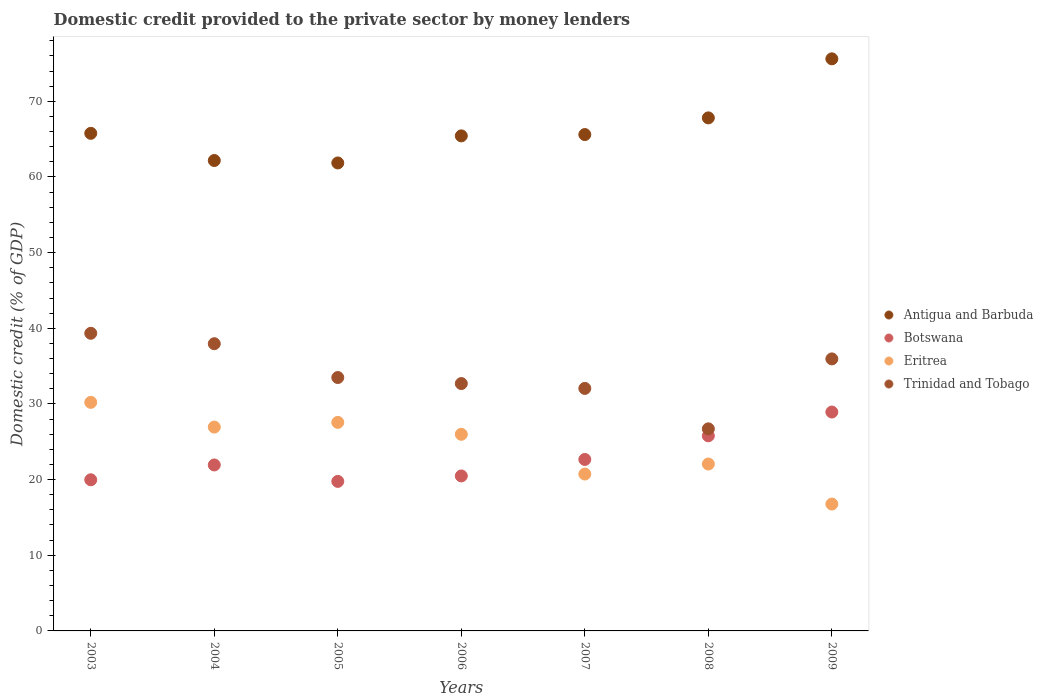How many different coloured dotlines are there?
Your response must be concise. 4. What is the domestic credit provided to the private sector by money lenders in Botswana in 2009?
Your response must be concise. 28.93. Across all years, what is the maximum domestic credit provided to the private sector by money lenders in Botswana?
Provide a short and direct response. 28.93. Across all years, what is the minimum domestic credit provided to the private sector by money lenders in Trinidad and Tobago?
Keep it short and to the point. 26.71. In which year was the domestic credit provided to the private sector by money lenders in Trinidad and Tobago maximum?
Provide a short and direct response. 2003. What is the total domestic credit provided to the private sector by money lenders in Eritrea in the graph?
Keep it short and to the point. 170.27. What is the difference between the domestic credit provided to the private sector by money lenders in Eritrea in 2003 and that in 2005?
Your answer should be compact. 2.65. What is the difference between the domestic credit provided to the private sector by money lenders in Trinidad and Tobago in 2004 and the domestic credit provided to the private sector by money lenders in Botswana in 2009?
Give a very brief answer. 9.03. What is the average domestic credit provided to the private sector by money lenders in Botswana per year?
Your response must be concise. 22.79. In the year 2007, what is the difference between the domestic credit provided to the private sector by money lenders in Antigua and Barbuda and domestic credit provided to the private sector by money lenders in Trinidad and Tobago?
Provide a short and direct response. 33.55. In how many years, is the domestic credit provided to the private sector by money lenders in Antigua and Barbuda greater than 52 %?
Provide a short and direct response. 7. What is the ratio of the domestic credit provided to the private sector by money lenders in Antigua and Barbuda in 2007 to that in 2009?
Your response must be concise. 0.87. What is the difference between the highest and the second highest domestic credit provided to the private sector by money lenders in Antigua and Barbuda?
Your response must be concise. 7.8. What is the difference between the highest and the lowest domestic credit provided to the private sector by money lenders in Antigua and Barbuda?
Offer a terse response. 13.76. In how many years, is the domestic credit provided to the private sector by money lenders in Antigua and Barbuda greater than the average domestic credit provided to the private sector by money lenders in Antigua and Barbuda taken over all years?
Keep it short and to the point. 2. Is the sum of the domestic credit provided to the private sector by money lenders in Trinidad and Tobago in 2006 and 2007 greater than the maximum domestic credit provided to the private sector by money lenders in Botswana across all years?
Keep it short and to the point. Yes. Is it the case that in every year, the sum of the domestic credit provided to the private sector by money lenders in Botswana and domestic credit provided to the private sector by money lenders in Eritrea  is greater than the sum of domestic credit provided to the private sector by money lenders in Trinidad and Tobago and domestic credit provided to the private sector by money lenders in Antigua and Barbuda?
Provide a succinct answer. No. Is it the case that in every year, the sum of the domestic credit provided to the private sector by money lenders in Antigua and Barbuda and domestic credit provided to the private sector by money lenders in Botswana  is greater than the domestic credit provided to the private sector by money lenders in Trinidad and Tobago?
Ensure brevity in your answer.  Yes. What is the difference between two consecutive major ticks on the Y-axis?
Your answer should be compact. 10. Are the values on the major ticks of Y-axis written in scientific E-notation?
Your answer should be very brief. No. Does the graph contain grids?
Keep it short and to the point. No. Where does the legend appear in the graph?
Make the answer very short. Center right. How are the legend labels stacked?
Your answer should be very brief. Vertical. What is the title of the graph?
Your answer should be very brief. Domestic credit provided to the private sector by money lenders. Does "North America" appear as one of the legend labels in the graph?
Ensure brevity in your answer.  No. What is the label or title of the X-axis?
Your answer should be very brief. Years. What is the label or title of the Y-axis?
Your response must be concise. Domestic credit (% of GDP). What is the Domestic credit (% of GDP) of Antigua and Barbuda in 2003?
Make the answer very short. 65.77. What is the Domestic credit (% of GDP) of Botswana in 2003?
Your answer should be compact. 19.98. What is the Domestic credit (% of GDP) in Eritrea in 2003?
Give a very brief answer. 30.21. What is the Domestic credit (% of GDP) of Trinidad and Tobago in 2003?
Offer a terse response. 39.34. What is the Domestic credit (% of GDP) of Antigua and Barbuda in 2004?
Make the answer very short. 62.18. What is the Domestic credit (% of GDP) of Botswana in 2004?
Your answer should be compact. 21.94. What is the Domestic credit (% of GDP) in Eritrea in 2004?
Keep it short and to the point. 26.94. What is the Domestic credit (% of GDP) in Trinidad and Tobago in 2004?
Your response must be concise. 37.96. What is the Domestic credit (% of GDP) in Antigua and Barbuda in 2005?
Provide a succinct answer. 61.85. What is the Domestic credit (% of GDP) of Botswana in 2005?
Offer a very short reply. 19.76. What is the Domestic credit (% of GDP) of Eritrea in 2005?
Give a very brief answer. 27.56. What is the Domestic credit (% of GDP) of Trinidad and Tobago in 2005?
Provide a short and direct response. 33.49. What is the Domestic credit (% of GDP) of Antigua and Barbuda in 2006?
Ensure brevity in your answer.  65.43. What is the Domestic credit (% of GDP) of Botswana in 2006?
Offer a terse response. 20.48. What is the Domestic credit (% of GDP) of Eritrea in 2006?
Offer a terse response. 25.99. What is the Domestic credit (% of GDP) in Trinidad and Tobago in 2006?
Give a very brief answer. 32.7. What is the Domestic credit (% of GDP) in Antigua and Barbuda in 2007?
Your answer should be compact. 65.61. What is the Domestic credit (% of GDP) in Botswana in 2007?
Provide a succinct answer. 22.66. What is the Domestic credit (% of GDP) of Eritrea in 2007?
Ensure brevity in your answer.  20.74. What is the Domestic credit (% of GDP) of Trinidad and Tobago in 2007?
Your answer should be compact. 32.05. What is the Domestic credit (% of GDP) in Antigua and Barbuda in 2008?
Your response must be concise. 67.81. What is the Domestic credit (% of GDP) of Botswana in 2008?
Your response must be concise. 25.79. What is the Domestic credit (% of GDP) in Eritrea in 2008?
Your answer should be very brief. 22.06. What is the Domestic credit (% of GDP) of Trinidad and Tobago in 2008?
Ensure brevity in your answer.  26.71. What is the Domestic credit (% of GDP) of Antigua and Barbuda in 2009?
Make the answer very short. 75.61. What is the Domestic credit (% of GDP) in Botswana in 2009?
Your response must be concise. 28.93. What is the Domestic credit (% of GDP) in Eritrea in 2009?
Give a very brief answer. 16.77. What is the Domestic credit (% of GDP) in Trinidad and Tobago in 2009?
Provide a short and direct response. 35.95. Across all years, what is the maximum Domestic credit (% of GDP) in Antigua and Barbuda?
Your answer should be very brief. 75.61. Across all years, what is the maximum Domestic credit (% of GDP) of Botswana?
Make the answer very short. 28.93. Across all years, what is the maximum Domestic credit (% of GDP) of Eritrea?
Offer a terse response. 30.21. Across all years, what is the maximum Domestic credit (% of GDP) in Trinidad and Tobago?
Give a very brief answer. 39.34. Across all years, what is the minimum Domestic credit (% of GDP) in Antigua and Barbuda?
Your response must be concise. 61.85. Across all years, what is the minimum Domestic credit (% of GDP) of Botswana?
Ensure brevity in your answer.  19.76. Across all years, what is the minimum Domestic credit (% of GDP) in Eritrea?
Your response must be concise. 16.77. Across all years, what is the minimum Domestic credit (% of GDP) of Trinidad and Tobago?
Offer a very short reply. 26.71. What is the total Domestic credit (% of GDP) in Antigua and Barbuda in the graph?
Keep it short and to the point. 464.26. What is the total Domestic credit (% of GDP) of Botswana in the graph?
Your answer should be very brief. 159.54. What is the total Domestic credit (% of GDP) in Eritrea in the graph?
Your answer should be compact. 170.27. What is the total Domestic credit (% of GDP) of Trinidad and Tobago in the graph?
Make the answer very short. 238.2. What is the difference between the Domestic credit (% of GDP) of Antigua and Barbuda in 2003 and that in 2004?
Ensure brevity in your answer.  3.59. What is the difference between the Domestic credit (% of GDP) of Botswana in 2003 and that in 2004?
Your answer should be very brief. -1.96. What is the difference between the Domestic credit (% of GDP) of Eritrea in 2003 and that in 2004?
Your answer should be very brief. 3.27. What is the difference between the Domestic credit (% of GDP) in Trinidad and Tobago in 2003 and that in 2004?
Ensure brevity in your answer.  1.38. What is the difference between the Domestic credit (% of GDP) in Antigua and Barbuda in 2003 and that in 2005?
Offer a very short reply. 3.91. What is the difference between the Domestic credit (% of GDP) in Botswana in 2003 and that in 2005?
Keep it short and to the point. 0.21. What is the difference between the Domestic credit (% of GDP) in Eritrea in 2003 and that in 2005?
Offer a very short reply. 2.65. What is the difference between the Domestic credit (% of GDP) of Trinidad and Tobago in 2003 and that in 2005?
Provide a succinct answer. 5.85. What is the difference between the Domestic credit (% of GDP) of Antigua and Barbuda in 2003 and that in 2006?
Provide a succinct answer. 0.33. What is the difference between the Domestic credit (% of GDP) of Botswana in 2003 and that in 2006?
Offer a terse response. -0.51. What is the difference between the Domestic credit (% of GDP) of Eritrea in 2003 and that in 2006?
Make the answer very short. 4.22. What is the difference between the Domestic credit (% of GDP) of Trinidad and Tobago in 2003 and that in 2006?
Your answer should be very brief. 6.64. What is the difference between the Domestic credit (% of GDP) of Antigua and Barbuda in 2003 and that in 2007?
Keep it short and to the point. 0.16. What is the difference between the Domestic credit (% of GDP) of Botswana in 2003 and that in 2007?
Your response must be concise. -2.69. What is the difference between the Domestic credit (% of GDP) of Eritrea in 2003 and that in 2007?
Offer a terse response. 9.47. What is the difference between the Domestic credit (% of GDP) of Trinidad and Tobago in 2003 and that in 2007?
Provide a short and direct response. 7.29. What is the difference between the Domestic credit (% of GDP) in Antigua and Barbuda in 2003 and that in 2008?
Make the answer very short. -2.04. What is the difference between the Domestic credit (% of GDP) in Botswana in 2003 and that in 2008?
Offer a very short reply. -5.81. What is the difference between the Domestic credit (% of GDP) of Eritrea in 2003 and that in 2008?
Ensure brevity in your answer.  8.15. What is the difference between the Domestic credit (% of GDP) in Trinidad and Tobago in 2003 and that in 2008?
Provide a succinct answer. 12.63. What is the difference between the Domestic credit (% of GDP) of Antigua and Barbuda in 2003 and that in 2009?
Provide a succinct answer. -9.85. What is the difference between the Domestic credit (% of GDP) of Botswana in 2003 and that in 2009?
Offer a very short reply. -8.95. What is the difference between the Domestic credit (% of GDP) of Eritrea in 2003 and that in 2009?
Your response must be concise. 13.44. What is the difference between the Domestic credit (% of GDP) of Trinidad and Tobago in 2003 and that in 2009?
Offer a terse response. 3.39. What is the difference between the Domestic credit (% of GDP) of Antigua and Barbuda in 2004 and that in 2005?
Provide a succinct answer. 0.32. What is the difference between the Domestic credit (% of GDP) in Botswana in 2004 and that in 2005?
Your response must be concise. 2.17. What is the difference between the Domestic credit (% of GDP) in Eritrea in 2004 and that in 2005?
Your response must be concise. -0.62. What is the difference between the Domestic credit (% of GDP) in Trinidad and Tobago in 2004 and that in 2005?
Your answer should be very brief. 4.47. What is the difference between the Domestic credit (% of GDP) of Antigua and Barbuda in 2004 and that in 2006?
Your answer should be compact. -3.26. What is the difference between the Domestic credit (% of GDP) in Botswana in 2004 and that in 2006?
Ensure brevity in your answer.  1.45. What is the difference between the Domestic credit (% of GDP) of Eritrea in 2004 and that in 2006?
Your response must be concise. 0.95. What is the difference between the Domestic credit (% of GDP) of Trinidad and Tobago in 2004 and that in 2006?
Offer a very short reply. 5.27. What is the difference between the Domestic credit (% of GDP) in Antigua and Barbuda in 2004 and that in 2007?
Your response must be concise. -3.43. What is the difference between the Domestic credit (% of GDP) in Botswana in 2004 and that in 2007?
Make the answer very short. -0.73. What is the difference between the Domestic credit (% of GDP) in Eritrea in 2004 and that in 2007?
Make the answer very short. 6.21. What is the difference between the Domestic credit (% of GDP) in Trinidad and Tobago in 2004 and that in 2007?
Ensure brevity in your answer.  5.91. What is the difference between the Domestic credit (% of GDP) of Antigua and Barbuda in 2004 and that in 2008?
Give a very brief answer. -5.63. What is the difference between the Domestic credit (% of GDP) of Botswana in 2004 and that in 2008?
Provide a short and direct response. -3.85. What is the difference between the Domestic credit (% of GDP) in Eritrea in 2004 and that in 2008?
Provide a succinct answer. 4.88. What is the difference between the Domestic credit (% of GDP) in Trinidad and Tobago in 2004 and that in 2008?
Provide a short and direct response. 11.25. What is the difference between the Domestic credit (% of GDP) in Antigua and Barbuda in 2004 and that in 2009?
Offer a terse response. -13.44. What is the difference between the Domestic credit (% of GDP) in Botswana in 2004 and that in 2009?
Provide a succinct answer. -7. What is the difference between the Domestic credit (% of GDP) in Eritrea in 2004 and that in 2009?
Provide a short and direct response. 10.17. What is the difference between the Domestic credit (% of GDP) of Trinidad and Tobago in 2004 and that in 2009?
Provide a succinct answer. 2.01. What is the difference between the Domestic credit (% of GDP) of Antigua and Barbuda in 2005 and that in 2006?
Offer a terse response. -3.58. What is the difference between the Domestic credit (% of GDP) of Botswana in 2005 and that in 2006?
Offer a very short reply. -0.72. What is the difference between the Domestic credit (% of GDP) in Eritrea in 2005 and that in 2006?
Keep it short and to the point. 1.57. What is the difference between the Domestic credit (% of GDP) in Trinidad and Tobago in 2005 and that in 2006?
Provide a succinct answer. 0.8. What is the difference between the Domestic credit (% of GDP) of Antigua and Barbuda in 2005 and that in 2007?
Provide a short and direct response. -3.75. What is the difference between the Domestic credit (% of GDP) in Botswana in 2005 and that in 2007?
Ensure brevity in your answer.  -2.9. What is the difference between the Domestic credit (% of GDP) in Eritrea in 2005 and that in 2007?
Provide a succinct answer. 6.83. What is the difference between the Domestic credit (% of GDP) of Trinidad and Tobago in 2005 and that in 2007?
Keep it short and to the point. 1.44. What is the difference between the Domestic credit (% of GDP) of Antigua and Barbuda in 2005 and that in 2008?
Give a very brief answer. -5.96. What is the difference between the Domestic credit (% of GDP) in Botswana in 2005 and that in 2008?
Your response must be concise. -6.02. What is the difference between the Domestic credit (% of GDP) of Eritrea in 2005 and that in 2008?
Offer a terse response. 5.5. What is the difference between the Domestic credit (% of GDP) in Trinidad and Tobago in 2005 and that in 2008?
Give a very brief answer. 6.78. What is the difference between the Domestic credit (% of GDP) in Antigua and Barbuda in 2005 and that in 2009?
Your response must be concise. -13.76. What is the difference between the Domestic credit (% of GDP) in Botswana in 2005 and that in 2009?
Offer a very short reply. -9.17. What is the difference between the Domestic credit (% of GDP) of Eritrea in 2005 and that in 2009?
Provide a short and direct response. 10.8. What is the difference between the Domestic credit (% of GDP) of Trinidad and Tobago in 2005 and that in 2009?
Offer a very short reply. -2.46. What is the difference between the Domestic credit (% of GDP) in Antigua and Barbuda in 2006 and that in 2007?
Your answer should be very brief. -0.17. What is the difference between the Domestic credit (% of GDP) of Botswana in 2006 and that in 2007?
Make the answer very short. -2.18. What is the difference between the Domestic credit (% of GDP) of Eritrea in 2006 and that in 2007?
Keep it short and to the point. 5.25. What is the difference between the Domestic credit (% of GDP) in Trinidad and Tobago in 2006 and that in 2007?
Provide a succinct answer. 0.64. What is the difference between the Domestic credit (% of GDP) in Antigua and Barbuda in 2006 and that in 2008?
Provide a succinct answer. -2.38. What is the difference between the Domestic credit (% of GDP) of Botswana in 2006 and that in 2008?
Offer a terse response. -5.3. What is the difference between the Domestic credit (% of GDP) in Eritrea in 2006 and that in 2008?
Keep it short and to the point. 3.93. What is the difference between the Domestic credit (% of GDP) in Trinidad and Tobago in 2006 and that in 2008?
Offer a terse response. 5.99. What is the difference between the Domestic credit (% of GDP) in Antigua and Barbuda in 2006 and that in 2009?
Ensure brevity in your answer.  -10.18. What is the difference between the Domestic credit (% of GDP) in Botswana in 2006 and that in 2009?
Your answer should be compact. -8.45. What is the difference between the Domestic credit (% of GDP) in Eritrea in 2006 and that in 2009?
Provide a short and direct response. 9.22. What is the difference between the Domestic credit (% of GDP) of Trinidad and Tobago in 2006 and that in 2009?
Keep it short and to the point. -3.26. What is the difference between the Domestic credit (% of GDP) of Antigua and Barbuda in 2007 and that in 2008?
Offer a very short reply. -2.2. What is the difference between the Domestic credit (% of GDP) of Botswana in 2007 and that in 2008?
Your answer should be compact. -3.12. What is the difference between the Domestic credit (% of GDP) of Eritrea in 2007 and that in 2008?
Provide a succinct answer. -1.33. What is the difference between the Domestic credit (% of GDP) of Trinidad and Tobago in 2007 and that in 2008?
Your response must be concise. 5.34. What is the difference between the Domestic credit (% of GDP) of Antigua and Barbuda in 2007 and that in 2009?
Offer a terse response. -10.01. What is the difference between the Domestic credit (% of GDP) of Botswana in 2007 and that in 2009?
Ensure brevity in your answer.  -6.27. What is the difference between the Domestic credit (% of GDP) in Eritrea in 2007 and that in 2009?
Offer a very short reply. 3.97. What is the difference between the Domestic credit (% of GDP) of Trinidad and Tobago in 2007 and that in 2009?
Offer a very short reply. -3.9. What is the difference between the Domestic credit (% of GDP) in Antigua and Barbuda in 2008 and that in 2009?
Make the answer very short. -7.8. What is the difference between the Domestic credit (% of GDP) in Botswana in 2008 and that in 2009?
Keep it short and to the point. -3.14. What is the difference between the Domestic credit (% of GDP) of Eritrea in 2008 and that in 2009?
Your response must be concise. 5.29. What is the difference between the Domestic credit (% of GDP) in Trinidad and Tobago in 2008 and that in 2009?
Keep it short and to the point. -9.25. What is the difference between the Domestic credit (% of GDP) in Antigua and Barbuda in 2003 and the Domestic credit (% of GDP) in Botswana in 2004?
Give a very brief answer. 43.83. What is the difference between the Domestic credit (% of GDP) of Antigua and Barbuda in 2003 and the Domestic credit (% of GDP) of Eritrea in 2004?
Your answer should be very brief. 38.83. What is the difference between the Domestic credit (% of GDP) of Antigua and Barbuda in 2003 and the Domestic credit (% of GDP) of Trinidad and Tobago in 2004?
Provide a succinct answer. 27.81. What is the difference between the Domestic credit (% of GDP) in Botswana in 2003 and the Domestic credit (% of GDP) in Eritrea in 2004?
Make the answer very short. -6.97. What is the difference between the Domestic credit (% of GDP) of Botswana in 2003 and the Domestic credit (% of GDP) of Trinidad and Tobago in 2004?
Offer a terse response. -17.98. What is the difference between the Domestic credit (% of GDP) in Eritrea in 2003 and the Domestic credit (% of GDP) in Trinidad and Tobago in 2004?
Provide a short and direct response. -7.75. What is the difference between the Domestic credit (% of GDP) in Antigua and Barbuda in 2003 and the Domestic credit (% of GDP) in Botswana in 2005?
Ensure brevity in your answer.  46. What is the difference between the Domestic credit (% of GDP) of Antigua and Barbuda in 2003 and the Domestic credit (% of GDP) of Eritrea in 2005?
Provide a succinct answer. 38.2. What is the difference between the Domestic credit (% of GDP) in Antigua and Barbuda in 2003 and the Domestic credit (% of GDP) in Trinidad and Tobago in 2005?
Your response must be concise. 32.28. What is the difference between the Domestic credit (% of GDP) in Botswana in 2003 and the Domestic credit (% of GDP) in Eritrea in 2005?
Keep it short and to the point. -7.59. What is the difference between the Domestic credit (% of GDP) of Botswana in 2003 and the Domestic credit (% of GDP) of Trinidad and Tobago in 2005?
Give a very brief answer. -13.51. What is the difference between the Domestic credit (% of GDP) in Eritrea in 2003 and the Domestic credit (% of GDP) in Trinidad and Tobago in 2005?
Ensure brevity in your answer.  -3.28. What is the difference between the Domestic credit (% of GDP) in Antigua and Barbuda in 2003 and the Domestic credit (% of GDP) in Botswana in 2006?
Your answer should be very brief. 45.28. What is the difference between the Domestic credit (% of GDP) of Antigua and Barbuda in 2003 and the Domestic credit (% of GDP) of Eritrea in 2006?
Offer a terse response. 39.78. What is the difference between the Domestic credit (% of GDP) of Antigua and Barbuda in 2003 and the Domestic credit (% of GDP) of Trinidad and Tobago in 2006?
Provide a short and direct response. 33.07. What is the difference between the Domestic credit (% of GDP) of Botswana in 2003 and the Domestic credit (% of GDP) of Eritrea in 2006?
Offer a very short reply. -6.01. What is the difference between the Domestic credit (% of GDP) of Botswana in 2003 and the Domestic credit (% of GDP) of Trinidad and Tobago in 2006?
Provide a succinct answer. -12.72. What is the difference between the Domestic credit (% of GDP) in Eritrea in 2003 and the Domestic credit (% of GDP) in Trinidad and Tobago in 2006?
Give a very brief answer. -2.49. What is the difference between the Domestic credit (% of GDP) of Antigua and Barbuda in 2003 and the Domestic credit (% of GDP) of Botswana in 2007?
Your answer should be compact. 43.1. What is the difference between the Domestic credit (% of GDP) of Antigua and Barbuda in 2003 and the Domestic credit (% of GDP) of Eritrea in 2007?
Make the answer very short. 45.03. What is the difference between the Domestic credit (% of GDP) in Antigua and Barbuda in 2003 and the Domestic credit (% of GDP) in Trinidad and Tobago in 2007?
Provide a succinct answer. 33.72. What is the difference between the Domestic credit (% of GDP) in Botswana in 2003 and the Domestic credit (% of GDP) in Eritrea in 2007?
Your answer should be very brief. -0.76. What is the difference between the Domestic credit (% of GDP) in Botswana in 2003 and the Domestic credit (% of GDP) in Trinidad and Tobago in 2007?
Give a very brief answer. -12.08. What is the difference between the Domestic credit (% of GDP) in Eritrea in 2003 and the Domestic credit (% of GDP) in Trinidad and Tobago in 2007?
Provide a succinct answer. -1.84. What is the difference between the Domestic credit (% of GDP) in Antigua and Barbuda in 2003 and the Domestic credit (% of GDP) in Botswana in 2008?
Make the answer very short. 39.98. What is the difference between the Domestic credit (% of GDP) of Antigua and Barbuda in 2003 and the Domestic credit (% of GDP) of Eritrea in 2008?
Give a very brief answer. 43.71. What is the difference between the Domestic credit (% of GDP) of Antigua and Barbuda in 2003 and the Domestic credit (% of GDP) of Trinidad and Tobago in 2008?
Make the answer very short. 39.06. What is the difference between the Domestic credit (% of GDP) in Botswana in 2003 and the Domestic credit (% of GDP) in Eritrea in 2008?
Provide a short and direct response. -2.08. What is the difference between the Domestic credit (% of GDP) in Botswana in 2003 and the Domestic credit (% of GDP) in Trinidad and Tobago in 2008?
Give a very brief answer. -6.73. What is the difference between the Domestic credit (% of GDP) of Eritrea in 2003 and the Domestic credit (% of GDP) of Trinidad and Tobago in 2008?
Provide a succinct answer. 3.5. What is the difference between the Domestic credit (% of GDP) of Antigua and Barbuda in 2003 and the Domestic credit (% of GDP) of Botswana in 2009?
Give a very brief answer. 36.84. What is the difference between the Domestic credit (% of GDP) in Antigua and Barbuda in 2003 and the Domestic credit (% of GDP) in Eritrea in 2009?
Give a very brief answer. 49. What is the difference between the Domestic credit (% of GDP) of Antigua and Barbuda in 2003 and the Domestic credit (% of GDP) of Trinidad and Tobago in 2009?
Your response must be concise. 29.81. What is the difference between the Domestic credit (% of GDP) in Botswana in 2003 and the Domestic credit (% of GDP) in Eritrea in 2009?
Your response must be concise. 3.21. What is the difference between the Domestic credit (% of GDP) in Botswana in 2003 and the Domestic credit (% of GDP) in Trinidad and Tobago in 2009?
Give a very brief answer. -15.98. What is the difference between the Domestic credit (% of GDP) in Eritrea in 2003 and the Domestic credit (% of GDP) in Trinidad and Tobago in 2009?
Provide a succinct answer. -5.74. What is the difference between the Domestic credit (% of GDP) in Antigua and Barbuda in 2004 and the Domestic credit (% of GDP) in Botswana in 2005?
Keep it short and to the point. 42.41. What is the difference between the Domestic credit (% of GDP) of Antigua and Barbuda in 2004 and the Domestic credit (% of GDP) of Eritrea in 2005?
Your answer should be very brief. 34.61. What is the difference between the Domestic credit (% of GDP) in Antigua and Barbuda in 2004 and the Domestic credit (% of GDP) in Trinidad and Tobago in 2005?
Your response must be concise. 28.68. What is the difference between the Domestic credit (% of GDP) in Botswana in 2004 and the Domestic credit (% of GDP) in Eritrea in 2005?
Provide a short and direct response. -5.63. What is the difference between the Domestic credit (% of GDP) in Botswana in 2004 and the Domestic credit (% of GDP) in Trinidad and Tobago in 2005?
Your answer should be very brief. -11.56. What is the difference between the Domestic credit (% of GDP) in Eritrea in 2004 and the Domestic credit (% of GDP) in Trinidad and Tobago in 2005?
Keep it short and to the point. -6.55. What is the difference between the Domestic credit (% of GDP) of Antigua and Barbuda in 2004 and the Domestic credit (% of GDP) of Botswana in 2006?
Offer a very short reply. 41.69. What is the difference between the Domestic credit (% of GDP) of Antigua and Barbuda in 2004 and the Domestic credit (% of GDP) of Eritrea in 2006?
Provide a short and direct response. 36.19. What is the difference between the Domestic credit (% of GDP) in Antigua and Barbuda in 2004 and the Domestic credit (% of GDP) in Trinidad and Tobago in 2006?
Offer a terse response. 29.48. What is the difference between the Domestic credit (% of GDP) in Botswana in 2004 and the Domestic credit (% of GDP) in Eritrea in 2006?
Offer a terse response. -4.05. What is the difference between the Domestic credit (% of GDP) in Botswana in 2004 and the Domestic credit (% of GDP) in Trinidad and Tobago in 2006?
Offer a terse response. -10.76. What is the difference between the Domestic credit (% of GDP) in Eritrea in 2004 and the Domestic credit (% of GDP) in Trinidad and Tobago in 2006?
Ensure brevity in your answer.  -5.75. What is the difference between the Domestic credit (% of GDP) in Antigua and Barbuda in 2004 and the Domestic credit (% of GDP) in Botswana in 2007?
Offer a terse response. 39.51. What is the difference between the Domestic credit (% of GDP) of Antigua and Barbuda in 2004 and the Domestic credit (% of GDP) of Eritrea in 2007?
Offer a terse response. 41.44. What is the difference between the Domestic credit (% of GDP) of Antigua and Barbuda in 2004 and the Domestic credit (% of GDP) of Trinidad and Tobago in 2007?
Keep it short and to the point. 30.12. What is the difference between the Domestic credit (% of GDP) of Botswana in 2004 and the Domestic credit (% of GDP) of Trinidad and Tobago in 2007?
Your answer should be very brief. -10.12. What is the difference between the Domestic credit (% of GDP) in Eritrea in 2004 and the Domestic credit (% of GDP) in Trinidad and Tobago in 2007?
Give a very brief answer. -5.11. What is the difference between the Domestic credit (% of GDP) of Antigua and Barbuda in 2004 and the Domestic credit (% of GDP) of Botswana in 2008?
Ensure brevity in your answer.  36.39. What is the difference between the Domestic credit (% of GDP) of Antigua and Barbuda in 2004 and the Domestic credit (% of GDP) of Eritrea in 2008?
Provide a short and direct response. 40.11. What is the difference between the Domestic credit (% of GDP) in Antigua and Barbuda in 2004 and the Domestic credit (% of GDP) in Trinidad and Tobago in 2008?
Provide a short and direct response. 35.47. What is the difference between the Domestic credit (% of GDP) of Botswana in 2004 and the Domestic credit (% of GDP) of Eritrea in 2008?
Give a very brief answer. -0.13. What is the difference between the Domestic credit (% of GDP) of Botswana in 2004 and the Domestic credit (% of GDP) of Trinidad and Tobago in 2008?
Make the answer very short. -4.77. What is the difference between the Domestic credit (% of GDP) of Eritrea in 2004 and the Domestic credit (% of GDP) of Trinidad and Tobago in 2008?
Offer a very short reply. 0.23. What is the difference between the Domestic credit (% of GDP) of Antigua and Barbuda in 2004 and the Domestic credit (% of GDP) of Botswana in 2009?
Provide a short and direct response. 33.24. What is the difference between the Domestic credit (% of GDP) of Antigua and Barbuda in 2004 and the Domestic credit (% of GDP) of Eritrea in 2009?
Offer a very short reply. 45.41. What is the difference between the Domestic credit (% of GDP) of Antigua and Barbuda in 2004 and the Domestic credit (% of GDP) of Trinidad and Tobago in 2009?
Make the answer very short. 26.22. What is the difference between the Domestic credit (% of GDP) in Botswana in 2004 and the Domestic credit (% of GDP) in Eritrea in 2009?
Provide a succinct answer. 5.17. What is the difference between the Domestic credit (% of GDP) in Botswana in 2004 and the Domestic credit (% of GDP) in Trinidad and Tobago in 2009?
Offer a very short reply. -14.02. What is the difference between the Domestic credit (% of GDP) in Eritrea in 2004 and the Domestic credit (% of GDP) in Trinidad and Tobago in 2009?
Offer a terse response. -9.01. What is the difference between the Domestic credit (% of GDP) of Antigua and Barbuda in 2005 and the Domestic credit (% of GDP) of Botswana in 2006?
Give a very brief answer. 41.37. What is the difference between the Domestic credit (% of GDP) in Antigua and Barbuda in 2005 and the Domestic credit (% of GDP) in Eritrea in 2006?
Your answer should be very brief. 35.86. What is the difference between the Domestic credit (% of GDP) in Antigua and Barbuda in 2005 and the Domestic credit (% of GDP) in Trinidad and Tobago in 2006?
Your answer should be very brief. 29.16. What is the difference between the Domestic credit (% of GDP) in Botswana in 2005 and the Domestic credit (% of GDP) in Eritrea in 2006?
Ensure brevity in your answer.  -6.22. What is the difference between the Domestic credit (% of GDP) of Botswana in 2005 and the Domestic credit (% of GDP) of Trinidad and Tobago in 2006?
Provide a short and direct response. -12.93. What is the difference between the Domestic credit (% of GDP) of Eritrea in 2005 and the Domestic credit (% of GDP) of Trinidad and Tobago in 2006?
Make the answer very short. -5.13. What is the difference between the Domestic credit (% of GDP) of Antigua and Barbuda in 2005 and the Domestic credit (% of GDP) of Botswana in 2007?
Provide a succinct answer. 39.19. What is the difference between the Domestic credit (% of GDP) in Antigua and Barbuda in 2005 and the Domestic credit (% of GDP) in Eritrea in 2007?
Provide a succinct answer. 41.12. What is the difference between the Domestic credit (% of GDP) of Antigua and Barbuda in 2005 and the Domestic credit (% of GDP) of Trinidad and Tobago in 2007?
Offer a very short reply. 29.8. What is the difference between the Domestic credit (% of GDP) in Botswana in 2005 and the Domestic credit (% of GDP) in Eritrea in 2007?
Your answer should be very brief. -0.97. What is the difference between the Domestic credit (% of GDP) in Botswana in 2005 and the Domestic credit (% of GDP) in Trinidad and Tobago in 2007?
Ensure brevity in your answer.  -12.29. What is the difference between the Domestic credit (% of GDP) of Eritrea in 2005 and the Domestic credit (% of GDP) of Trinidad and Tobago in 2007?
Keep it short and to the point. -4.49. What is the difference between the Domestic credit (% of GDP) in Antigua and Barbuda in 2005 and the Domestic credit (% of GDP) in Botswana in 2008?
Make the answer very short. 36.07. What is the difference between the Domestic credit (% of GDP) of Antigua and Barbuda in 2005 and the Domestic credit (% of GDP) of Eritrea in 2008?
Provide a succinct answer. 39.79. What is the difference between the Domestic credit (% of GDP) of Antigua and Barbuda in 2005 and the Domestic credit (% of GDP) of Trinidad and Tobago in 2008?
Make the answer very short. 35.14. What is the difference between the Domestic credit (% of GDP) in Botswana in 2005 and the Domestic credit (% of GDP) in Eritrea in 2008?
Your answer should be very brief. -2.3. What is the difference between the Domestic credit (% of GDP) of Botswana in 2005 and the Domestic credit (% of GDP) of Trinidad and Tobago in 2008?
Keep it short and to the point. -6.94. What is the difference between the Domestic credit (% of GDP) of Eritrea in 2005 and the Domestic credit (% of GDP) of Trinidad and Tobago in 2008?
Offer a very short reply. 0.85. What is the difference between the Domestic credit (% of GDP) of Antigua and Barbuda in 2005 and the Domestic credit (% of GDP) of Botswana in 2009?
Keep it short and to the point. 32.92. What is the difference between the Domestic credit (% of GDP) of Antigua and Barbuda in 2005 and the Domestic credit (% of GDP) of Eritrea in 2009?
Ensure brevity in your answer.  45.09. What is the difference between the Domestic credit (% of GDP) of Antigua and Barbuda in 2005 and the Domestic credit (% of GDP) of Trinidad and Tobago in 2009?
Your answer should be very brief. 25.9. What is the difference between the Domestic credit (% of GDP) of Botswana in 2005 and the Domestic credit (% of GDP) of Eritrea in 2009?
Provide a short and direct response. 3. What is the difference between the Domestic credit (% of GDP) of Botswana in 2005 and the Domestic credit (% of GDP) of Trinidad and Tobago in 2009?
Offer a terse response. -16.19. What is the difference between the Domestic credit (% of GDP) in Eritrea in 2005 and the Domestic credit (% of GDP) in Trinidad and Tobago in 2009?
Make the answer very short. -8.39. What is the difference between the Domestic credit (% of GDP) of Antigua and Barbuda in 2006 and the Domestic credit (% of GDP) of Botswana in 2007?
Your answer should be compact. 42.77. What is the difference between the Domestic credit (% of GDP) of Antigua and Barbuda in 2006 and the Domestic credit (% of GDP) of Eritrea in 2007?
Your response must be concise. 44.7. What is the difference between the Domestic credit (% of GDP) of Antigua and Barbuda in 2006 and the Domestic credit (% of GDP) of Trinidad and Tobago in 2007?
Provide a succinct answer. 33.38. What is the difference between the Domestic credit (% of GDP) of Botswana in 2006 and the Domestic credit (% of GDP) of Eritrea in 2007?
Your response must be concise. -0.25. What is the difference between the Domestic credit (% of GDP) of Botswana in 2006 and the Domestic credit (% of GDP) of Trinidad and Tobago in 2007?
Give a very brief answer. -11.57. What is the difference between the Domestic credit (% of GDP) in Eritrea in 2006 and the Domestic credit (% of GDP) in Trinidad and Tobago in 2007?
Make the answer very short. -6.06. What is the difference between the Domestic credit (% of GDP) in Antigua and Barbuda in 2006 and the Domestic credit (% of GDP) in Botswana in 2008?
Offer a terse response. 39.65. What is the difference between the Domestic credit (% of GDP) of Antigua and Barbuda in 2006 and the Domestic credit (% of GDP) of Eritrea in 2008?
Keep it short and to the point. 43.37. What is the difference between the Domestic credit (% of GDP) of Antigua and Barbuda in 2006 and the Domestic credit (% of GDP) of Trinidad and Tobago in 2008?
Offer a very short reply. 38.73. What is the difference between the Domestic credit (% of GDP) of Botswana in 2006 and the Domestic credit (% of GDP) of Eritrea in 2008?
Make the answer very short. -1.58. What is the difference between the Domestic credit (% of GDP) of Botswana in 2006 and the Domestic credit (% of GDP) of Trinidad and Tobago in 2008?
Your answer should be very brief. -6.22. What is the difference between the Domestic credit (% of GDP) of Eritrea in 2006 and the Domestic credit (% of GDP) of Trinidad and Tobago in 2008?
Offer a terse response. -0.72. What is the difference between the Domestic credit (% of GDP) in Antigua and Barbuda in 2006 and the Domestic credit (% of GDP) in Botswana in 2009?
Your response must be concise. 36.5. What is the difference between the Domestic credit (% of GDP) in Antigua and Barbuda in 2006 and the Domestic credit (% of GDP) in Eritrea in 2009?
Provide a short and direct response. 48.67. What is the difference between the Domestic credit (% of GDP) in Antigua and Barbuda in 2006 and the Domestic credit (% of GDP) in Trinidad and Tobago in 2009?
Provide a short and direct response. 29.48. What is the difference between the Domestic credit (% of GDP) in Botswana in 2006 and the Domestic credit (% of GDP) in Eritrea in 2009?
Provide a succinct answer. 3.72. What is the difference between the Domestic credit (% of GDP) in Botswana in 2006 and the Domestic credit (% of GDP) in Trinidad and Tobago in 2009?
Provide a short and direct response. -15.47. What is the difference between the Domestic credit (% of GDP) in Eritrea in 2006 and the Domestic credit (% of GDP) in Trinidad and Tobago in 2009?
Your answer should be compact. -9.97. What is the difference between the Domestic credit (% of GDP) in Antigua and Barbuda in 2007 and the Domestic credit (% of GDP) in Botswana in 2008?
Provide a short and direct response. 39.82. What is the difference between the Domestic credit (% of GDP) of Antigua and Barbuda in 2007 and the Domestic credit (% of GDP) of Eritrea in 2008?
Your response must be concise. 43.55. What is the difference between the Domestic credit (% of GDP) in Antigua and Barbuda in 2007 and the Domestic credit (% of GDP) in Trinidad and Tobago in 2008?
Make the answer very short. 38.9. What is the difference between the Domestic credit (% of GDP) in Botswana in 2007 and the Domestic credit (% of GDP) in Eritrea in 2008?
Ensure brevity in your answer.  0.6. What is the difference between the Domestic credit (% of GDP) of Botswana in 2007 and the Domestic credit (% of GDP) of Trinidad and Tobago in 2008?
Offer a terse response. -4.04. What is the difference between the Domestic credit (% of GDP) in Eritrea in 2007 and the Domestic credit (% of GDP) in Trinidad and Tobago in 2008?
Your answer should be compact. -5.97. What is the difference between the Domestic credit (% of GDP) in Antigua and Barbuda in 2007 and the Domestic credit (% of GDP) in Botswana in 2009?
Provide a succinct answer. 36.67. What is the difference between the Domestic credit (% of GDP) in Antigua and Barbuda in 2007 and the Domestic credit (% of GDP) in Eritrea in 2009?
Keep it short and to the point. 48.84. What is the difference between the Domestic credit (% of GDP) of Antigua and Barbuda in 2007 and the Domestic credit (% of GDP) of Trinidad and Tobago in 2009?
Ensure brevity in your answer.  29.65. What is the difference between the Domestic credit (% of GDP) in Botswana in 2007 and the Domestic credit (% of GDP) in Eritrea in 2009?
Your answer should be compact. 5.9. What is the difference between the Domestic credit (% of GDP) of Botswana in 2007 and the Domestic credit (% of GDP) of Trinidad and Tobago in 2009?
Offer a terse response. -13.29. What is the difference between the Domestic credit (% of GDP) of Eritrea in 2007 and the Domestic credit (% of GDP) of Trinidad and Tobago in 2009?
Make the answer very short. -15.22. What is the difference between the Domestic credit (% of GDP) in Antigua and Barbuda in 2008 and the Domestic credit (% of GDP) in Botswana in 2009?
Offer a terse response. 38.88. What is the difference between the Domestic credit (% of GDP) in Antigua and Barbuda in 2008 and the Domestic credit (% of GDP) in Eritrea in 2009?
Offer a terse response. 51.04. What is the difference between the Domestic credit (% of GDP) of Antigua and Barbuda in 2008 and the Domestic credit (% of GDP) of Trinidad and Tobago in 2009?
Ensure brevity in your answer.  31.86. What is the difference between the Domestic credit (% of GDP) of Botswana in 2008 and the Domestic credit (% of GDP) of Eritrea in 2009?
Offer a very short reply. 9.02. What is the difference between the Domestic credit (% of GDP) in Botswana in 2008 and the Domestic credit (% of GDP) in Trinidad and Tobago in 2009?
Offer a terse response. -10.17. What is the difference between the Domestic credit (% of GDP) of Eritrea in 2008 and the Domestic credit (% of GDP) of Trinidad and Tobago in 2009?
Provide a short and direct response. -13.89. What is the average Domestic credit (% of GDP) of Antigua and Barbuda per year?
Offer a very short reply. 66.32. What is the average Domestic credit (% of GDP) of Botswana per year?
Provide a short and direct response. 22.79. What is the average Domestic credit (% of GDP) of Eritrea per year?
Offer a very short reply. 24.32. What is the average Domestic credit (% of GDP) in Trinidad and Tobago per year?
Your answer should be very brief. 34.03. In the year 2003, what is the difference between the Domestic credit (% of GDP) in Antigua and Barbuda and Domestic credit (% of GDP) in Botswana?
Make the answer very short. 45.79. In the year 2003, what is the difference between the Domestic credit (% of GDP) of Antigua and Barbuda and Domestic credit (% of GDP) of Eritrea?
Your answer should be compact. 35.56. In the year 2003, what is the difference between the Domestic credit (% of GDP) of Antigua and Barbuda and Domestic credit (% of GDP) of Trinidad and Tobago?
Your answer should be very brief. 26.43. In the year 2003, what is the difference between the Domestic credit (% of GDP) in Botswana and Domestic credit (% of GDP) in Eritrea?
Provide a succinct answer. -10.23. In the year 2003, what is the difference between the Domestic credit (% of GDP) in Botswana and Domestic credit (% of GDP) in Trinidad and Tobago?
Keep it short and to the point. -19.36. In the year 2003, what is the difference between the Domestic credit (% of GDP) of Eritrea and Domestic credit (% of GDP) of Trinidad and Tobago?
Offer a terse response. -9.13. In the year 2004, what is the difference between the Domestic credit (% of GDP) of Antigua and Barbuda and Domestic credit (% of GDP) of Botswana?
Your answer should be compact. 40.24. In the year 2004, what is the difference between the Domestic credit (% of GDP) of Antigua and Barbuda and Domestic credit (% of GDP) of Eritrea?
Keep it short and to the point. 35.23. In the year 2004, what is the difference between the Domestic credit (% of GDP) in Antigua and Barbuda and Domestic credit (% of GDP) in Trinidad and Tobago?
Your answer should be very brief. 24.21. In the year 2004, what is the difference between the Domestic credit (% of GDP) of Botswana and Domestic credit (% of GDP) of Eritrea?
Make the answer very short. -5.01. In the year 2004, what is the difference between the Domestic credit (% of GDP) in Botswana and Domestic credit (% of GDP) in Trinidad and Tobago?
Provide a short and direct response. -16.03. In the year 2004, what is the difference between the Domestic credit (% of GDP) in Eritrea and Domestic credit (% of GDP) in Trinidad and Tobago?
Make the answer very short. -11.02. In the year 2005, what is the difference between the Domestic credit (% of GDP) in Antigua and Barbuda and Domestic credit (% of GDP) in Botswana?
Give a very brief answer. 42.09. In the year 2005, what is the difference between the Domestic credit (% of GDP) in Antigua and Barbuda and Domestic credit (% of GDP) in Eritrea?
Make the answer very short. 34.29. In the year 2005, what is the difference between the Domestic credit (% of GDP) of Antigua and Barbuda and Domestic credit (% of GDP) of Trinidad and Tobago?
Offer a terse response. 28.36. In the year 2005, what is the difference between the Domestic credit (% of GDP) of Botswana and Domestic credit (% of GDP) of Eritrea?
Offer a terse response. -7.8. In the year 2005, what is the difference between the Domestic credit (% of GDP) in Botswana and Domestic credit (% of GDP) in Trinidad and Tobago?
Your answer should be compact. -13.73. In the year 2005, what is the difference between the Domestic credit (% of GDP) of Eritrea and Domestic credit (% of GDP) of Trinidad and Tobago?
Your answer should be very brief. -5.93. In the year 2006, what is the difference between the Domestic credit (% of GDP) of Antigua and Barbuda and Domestic credit (% of GDP) of Botswana?
Ensure brevity in your answer.  44.95. In the year 2006, what is the difference between the Domestic credit (% of GDP) of Antigua and Barbuda and Domestic credit (% of GDP) of Eritrea?
Ensure brevity in your answer.  39.45. In the year 2006, what is the difference between the Domestic credit (% of GDP) in Antigua and Barbuda and Domestic credit (% of GDP) in Trinidad and Tobago?
Keep it short and to the point. 32.74. In the year 2006, what is the difference between the Domestic credit (% of GDP) in Botswana and Domestic credit (% of GDP) in Eritrea?
Give a very brief answer. -5.5. In the year 2006, what is the difference between the Domestic credit (% of GDP) of Botswana and Domestic credit (% of GDP) of Trinidad and Tobago?
Make the answer very short. -12.21. In the year 2006, what is the difference between the Domestic credit (% of GDP) in Eritrea and Domestic credit (% of GDP) in Trinidad and Tobago?
Make the answer very short. -6.71. In the year 2007, what is the difference between the Domestic credit (% of GDP) of Antigua and Barbuda and Domestic credit (% of GDP) of Botswana?
Your answer should be very brief. 42.94. In the year 2007, what is the difference between the Domestic credit (% of GDP) in Antigua and Barbuda and Domestic credit (% of GDP) in Eritrea?
Ensure brevity in your answer.  44.87. In the year 2007, what is the difference between the Domestic credit (% of GDP) of Antigua and Barbuda and Domestic credit (% of GDP) of Trinidad and Tobago?
Provide a succinct answer. 33.55. In the year 2007, what is the difference between the Domestic credit (% of GDP) in Botswana and Domestic credit (% of GDP) in Eritrea?
Provide a short and direct response. 1.93. In the year 2007, what is the difference between the Domestic credit (% of GDP) in Botswana and Domestic credit (% of GDP) in Trinidad and Tobago?
Your answer should be compact. -9.39. In the year 2007, what is the difference between the Domestic credit (% of GDP) in Eritrea and Domestic credit (% of GDP) in Trinidad and Tobago?
Your response must be concise. -11.32. In the year 2008, what is the difference between the Domestic credit (% of GDP) in Antigua and Barbuda and Domestic credit (% of GDP) in Botswana?
Provide a succinct answer. 42.02. In the year 2008, what is the difference between the Domestic credit (% of GDP) in Antigua and Barbuda and Domestic credit (% of GDP) in Eritrea?
Give a very brief answer. 45.75. In the year 2008, what is the difference between the Domestic credit (% of GDP) in Antigua and Barbuda and Domestic credit (% of GDP) in Trinidad and Tobago?
Offer a terse response. 41.1. In the year 2008, what is the difference between the Domestic credit (% of GDP) in Botswana and Domestic credit (% of GDP) in Eritrea?
Keep it short and to the point. 3.73. In the year 2008, what is the difference between the Domestic credit (% of GDP) in Botswana and Domestic credit (% of GDP) in Trinidad and Tobago?
Make the answer very short. -0.92. In the year 2008, what is the difference between the Domestic credit (% of GDP) of Eritrea and Domestic credit (% of GDP) of Trinidad and Tobago?
Provide a succinct answer. -4.65. In the year 2009, what is the difference between the Domestic credit (% of GDP) of Antigua and Barbuda and Domestic credit (% of GDP) of Botswana?
Provide a succinct answer. 46.68. In the year 2009, what is the difference between the Domestic credit (% of GDP) in Antigua and Barbuda and Domestic credit (% of GDP) in Eritrea?
Offer a very short reply. 58.85. In the year 2009, what is the difference between the Domestic credit (% of GDP) in Antigua and Barbuda and Domestic credit (% of GDP) in Trinidad and Tobago?
Offer a very short reply. 39.66. In the year 2009, what is the difference between the Domestic credit (% of GDP) of Botswana and Domestic credit (% of GDP) of Eritrea?
Provide a short and direct response. 12.16. In the year 2009, what is the difference between the Domestic credit (% of GDP) in Botswana and Domestic credit (% of GDP) in Trinidad and Tobago?
Offer a very short reply. -7.02. In the year 2009, what is the difference between the Domestic credit (% of GDP) in Eritrea and Domestic credit (% of GDP) in Trinidad and Tobago?
Ensure brevity in your answer.  -19.19. What is the ratio of the Domestic credit (% of GDP) in Antigua and Barbuda in 2003 to that in 2004?
Provide a succinct answer. 1.06. What is the ratio of the Domestic credit (% of GDP) of Botswana in 2003 to that in 2004?
Ensure brevity in your answer.  0.91. What is the ratio of the Domestic credit (% of GDP) in Eritrea in 2003 to that in 2004?
Offer a very short reply. 1.12. What is the ratio of the Domestic credit (% of GDP) in Trinidad and Tobago in 2003 to that in 2004?
Provide a short and direct response. 1.04. What is the ratio of the Domestic credit (% of GDP) of Antigua and Barbuda in 2003 to that in 2005?
Give a very brief answer. 1.06. What is the ratio of the Domestic credit (% of GDP) in Botswana in 2003 to that in 2005?
Your answer should be very brief. 1.01. What is the ratio of the Domestic credit (% of GDP) in Eritrea in 2003 to that in 2005?
Offer a terse response. 1.1. What is the ratio of the Domestic credit (% of GDP) of Trinidad and Tobago in 2003 to that in 2005?
Your response must be concise. 1.17. What is the ratio of the Domestic credit (% of GDP) in Antigua and Barbuda in 2003 to that in 2006?
Give a very brief answer. 1.01. What is the ratio of the Domestic credit (% of GDP) of Botswana in 2003 to that in 2006?
Your response must be concise. 0.98. What is the ratio of the Domestic credit (% of GDP) of Eritrea in 2003 to that in 2006?
Provide a succinct answer. 1.16. What is the ratio of the Domestic credit (% of GDP) in Trinidad and Tobago in 2003 to that in 2006?
Keep it short and to the point. 1.2. What is the ratio of the Domestic credit (% of GDP) in Antigua and Barbuda in 2003 to that in 2007?
Give a very brief answer. 1. What is the ratio of the Domestic credit (% of GDP) in Botswana in 2003 to that in 2007?
Keep it short and to the point. 0.88. What is the ratio of the Domestic credit (% of GDP) in Eritrea in 2003 to that in 2007?
Offer a very short reply. 1.46. What is the ratio of the Domestic credit (% of GDP) of Trinidad and Tobago in 2003 to that in 2007?
Give a very brief answer. 1.23. What is the ratio of the Domestic credit (% of GDP) in Antigua and Barbuda in 2003 to that in 2008?
Your answer should be very brief. 0.97. What is the ratio of the Domestic credit (% of GDP) in Botswana in 2003 to that in 2008?
Offer a very short reply. 0.77. What is the ratio of the Domestic credit (% of GDP) in Eritrea in 2003 to that in 2008?
Provide a short and direct response. 1.37. What is the ratio of the Domestic credit (% of GDP) of Trinidad and Tobago in 2003 to that in 2008?
Keep it short and to the point. 1.47. What is the ratio of the Domestic credit (% of GDP) in Antigua and Barbuda in 2003 to that in 2009?
Offer a very short reply. 0.87. What is the ratio of the Domestic credit (% of GDP) in Botswana in 2003 to that in 2009?
Your answer should be very brief. 0.69. What is the ratio of the Domestic credit (% of GDP) in Eritrea in 2003 to that in 2009?
Your response must be concise. 1.8. What is the ratio of the Domestic credit (% of GDP) in Trinidad and Tobago in 2003 to that in 2009?
Offer a very short reply. 1.09. What is the ratio of the Domestic credit (% of GDP) in Antigua and Barbuda in 2004 to that in 2005?
Provide a succinct answer. 1.01. What is the ratio of the Domestic credit (% of GDP) in Botswana in 2004 to that in 2005?
Offer a terse response. 1.11. What is the ratio of the Domestic credit (% of GDP) in Eritrea in 2004 to that in 2005?
Provide a succinct answer. 0.98. What is the ratio of the Domestic credit (% of GDP) in Trinidad and Tobago in 2004 to that in 2005?
Give a very brief answer. 1.13. What is the ratio of the Domestic credit (% of GDP) of Antigua and Barbuda in 2004 to that in 2006?
Provide a short and direct response. 0.95. What is the ratio of the Domestic credit (% of GDP) of Botswana in 2004 to that in 2006?
Keep it short and to the point. 1.07. What is the ratio of the Domestic credit (% of GDP) of Eritrea in 2004 to that in 2006?
Offer a very short reply. 1.04. What is the ratio of the Domestic credit (% of GDP) of Trinidad and Tobago in 2004 to that in 2006?
Your answer should be very brief. 1.16. What is the ratio of the Domestic credit (% of GDP) in Antigua and Barbuda in 2004 to that in 2007?
Offer a terse response. 0.95. What is the ratio of the Domestic credit (% of GDP) of Botswana in 2004 to that in 2007?
Your response must be concise. 0.97. What is the ratio of the Domestic credit (% of GDP) of Eritrea in 2004 to that in 2007?
Ensure brevity in your answer.  1.3. What is the ratio of the Domestic credit (% of GDP) in Trinidad and Tobago in 2004 to that in 2007?
Your response must be concise. 1.18. What is the ratio of the Domestic credit (% of GDP) in Antigua and Barbuda in 2004 to that in 2008?
Offer a terse response. 0.92. What is the ratio of the Domestic credit (% of GDP) in Botswana in 2004 to that in 2008?
Ensure brevity in your answer.  0.85. What is the ratio of the Domestic credit (% of GDP) of Eritrea in 2004 to that in 2008?
Provide a succinct answer. 1.22. What is the ratio of the Domestic credit (% of GDP) of Trinidad and Tobago in 2004 to that in 2008?
Ensure brevity in your answer.  1.42. What is the ratio of the Domestic credit (% of GDP) in Antigua and Barbuda in 2004 to that in 2009?
Make the answer very short. 0.82. What is the ratio of the Domestic credit (% of GDP) of Botswana in 2004 to that in 2009?
Provide a short and direct response. 0.76. What is the ratio of the Domestic credit (% of GDP) of Eritrea in 2004 to that in 2009?
Give a very brief answer. 1.61. What is the ratio of the Domestic credit (% of GDP) in Trinidad and Tobago in 2004 to that in 2009?
Keep it short and to the point. 1.06. What is the ratio of the Domestic credit (% of GDP) in Antigua and Barbuda in 2005 to that in 2006?
Provide a succinct answer. 0.95. What is the ratio of the Domestic credit (% of GDP) of Botswana in 2005 to that in 2006?
Your answer should be compact. 0.96. What is the ratio of the Domestic credit (% of GDP) in Eritrea in 2005 to that in 2006?
Ensure brevity in your answer.  1.06. What is the ratio of the Domestic credit (% of GDP) of Trinidad and Tobago in 2005 to that in 2006?
Your answer should be very brief. 1.02. What is the ratio of the Domestic credit (% of GDP) of Antigua and Barbuda in 2005 to that in 2007?
Offer a terse response. 0.94. What is the ratio of the Domestic credit (% of GDP) of Botswana in 2005 to that in 2007?
Your answer should be compact. 0.87. What is the ratio of the Domestic credit (% of GDP) of Eritrea in 2005 to that in 2007?
Make the answer very short. 1.33. What is the ratio of the Domestic credit (% of GDP) in Trinidad and Tobago in 2005 to that in 2007?
Give a very brief answer. 1.04. What is the ratio of the Domestic credit (% of GDP) in Antigua and Barbuda in 2005 to that in 2008?
Offer a very short reply. 0.91. What is the ratio of the Domestic credit (% of GDP) in Botswana in 2005 to that in 2008?
Your response must be concise. 0.77. What is the ratio of the Domestic credit (% of GDP) in Eritrea in 2005 to that in 2008?
Your answer should be very brief. 1.25. What is the ratio of the Domestic credit (% of GDP) in Trinidad and Tobago in 2005 to that in 2008?
Provide a succinct answer. 1.25. What is the ratio of the Domestic credit (% of GDP) in Antigua and Barbuda in 2005 to that in 2009?
Make the answer very short. 0.82. What is the ratio of the Domestic credit (% of GDP) of Botswana in 2005 to that in 2009?
Your answer should be very brief. 0.68. What is the ratio of the Domestic credit (% of GDP) in Eritrea in 2005 to that in 2009?
Give a very brief answer. 1.64. What is the ratio of the Domestic credit (% of GDP) of Trinidad and Tobago in 2005 to that in 2009?
Offer a very short reply. 0.93. What is the ratio of the Domestic credit (% of GDP) in Antigua and Barbuda in 2006 to that in 2007?
Your response must be concise. 1. What is the ratio of the Domestic credit (% of GDP) in Botswana in 2006 to that in 2007?
Offer a very short reply. 0.9. What is the ratio of the Domestic credit (% of GDP) in Eritrea in 2006 to that in 2007?
Offer a terse response. 1.25. What is the ratio of the Domestic credit (% of GDP) in Trinidad and Tobago in 2006 to that in 2007?
Offer a terse response. 1.02. What is the ratio of the Domestic credit (% of GDP) in Antigua and Barbuda in 2006 to that in 2008?
Provide a succinct answer. 0.96. What is the ratio of the Domestic credit (% of GDP) in Botswana in 2006 to that in 2008?
Make the answer very short. 0.79. What is the ratio of the Domestic credit (% of GDP) of Eritrea in 2006 to that in 2008?
Ensure brevity in your answer.  1.18. What is the ratio of the Domestic credit (% of GDP) in Trinidad and Tobago in 2006 to that in 2008?
Provide a succinct answer. 1.22. What is the ratio of the Domestic credit (% of GDP) in Antigua and Barbuda in 2006 to that in 2009?
Your response must be concise. 0.87. What is the ratio of the Domestic credit (% of GDP) of Botswana in 2006 to that in 2009?
Ensure brevity in your answer.  0.71. What is the ratio of the Domestic credit (% of GDP) in Eritrea in 2006 to that in 2009?
Give a very brief answer. 1.55. What is the ratio of the Domestic credit (% of GDP) in Trinidad and Tobago in 2006 to that in 2009?
Offer a terse response. 0.91. What is the ratio of the Domestic credit (% of GDP) of Antigua and Barbuda in 2007 to that in 2008?
Offer a terse response. 0.97. What is the ratio of the Domestic credit (% of GDP) in Botswana in 2007 to that in 2008?
Your answer should be compact. 0.88. What is the ratio of the Domestic credit (% of GDP) in Eritrea in 2007 to that in 2008?
Give a very brief answer. 0.94. What is the ratio of the Domestic credit (% of GDP) of Trinidad and Tobago in 2007 to that in 2008?
Offer a terse response. 1.2. What is the ratio of the Domestic credit (% of GDP) in Antigua and Barbuda in 2007 to that in 2009?
Provide a short and direct response. 0.87. What is the ratio of the Domestic credit (% of GDP) in Botswana in 2007 to that in 2009?
Keep it short and to the point. 0.78. What is the ratio of the Domestic credit (% of GDP) of Eritrea in 2007 to that in 2009?
Give a very brief answer. 1.24. What is the ratio of the Domestic credit (% of GDP) in Trinidad and Tobago in 2007 to that in 2009?
Your response must be concise. 0.89. What is the ratio of the Domestic credit (% of GDP) in Antigua and Barbuda in 2008 to that in 2009?
Offer a very short reply. 0.9. What is the ratio of the Domestic credit (% of GDP) of Botswana in 2008 to that in 2009?
Offer a terse response. 0.89. What is the ratio of the Domestic credit (% of GDP) of Eritrea in 2008 to that in 2009?
Provide a short and direct response. 1.32. What is the ratio of the Domestic credit (% of GDP) of Trinidad and Tobago in 2008 to that in 2009?
Provide a short and direct response. 0.74. What is the difference between the highest and the second highest Domestic credit (% of GDP) in Antigua and Barbuda?
Offer a terse response. 7.8. What is the difference between the highest and the second highest Domestic credit (% of GDP) in Botswana?
Provide a short and direct response. 3.14. What is the difference between the highest and the second highest Domestic credit (% of GDP) in Eritrea?
Provide a succinct answer. 2.65. What is the difference between the highest and the second highest Domestic credit (% of GDP) in Trinidad and Tobago?
Your answer should be compact. 1.38. What is the difference between the highest and the lowest Domestic credit (% of GDP) of Antigua and Barbuda?
Offer a very short reply. 13.76. What is the difference between the highest and the lowest Domestic credit (% of GDP) of Botswana?
Provide a short and direct response. 9.17. What is the difference between the highest and the lowest Domestic credit (% of GDP) in Eritrea?
Offer a terse response. 13.44. What is the difference between the highest and the lowest Domestic credit (% of GDP) of Trinidad and Tobago?
Make the answer very short. 12.63. 